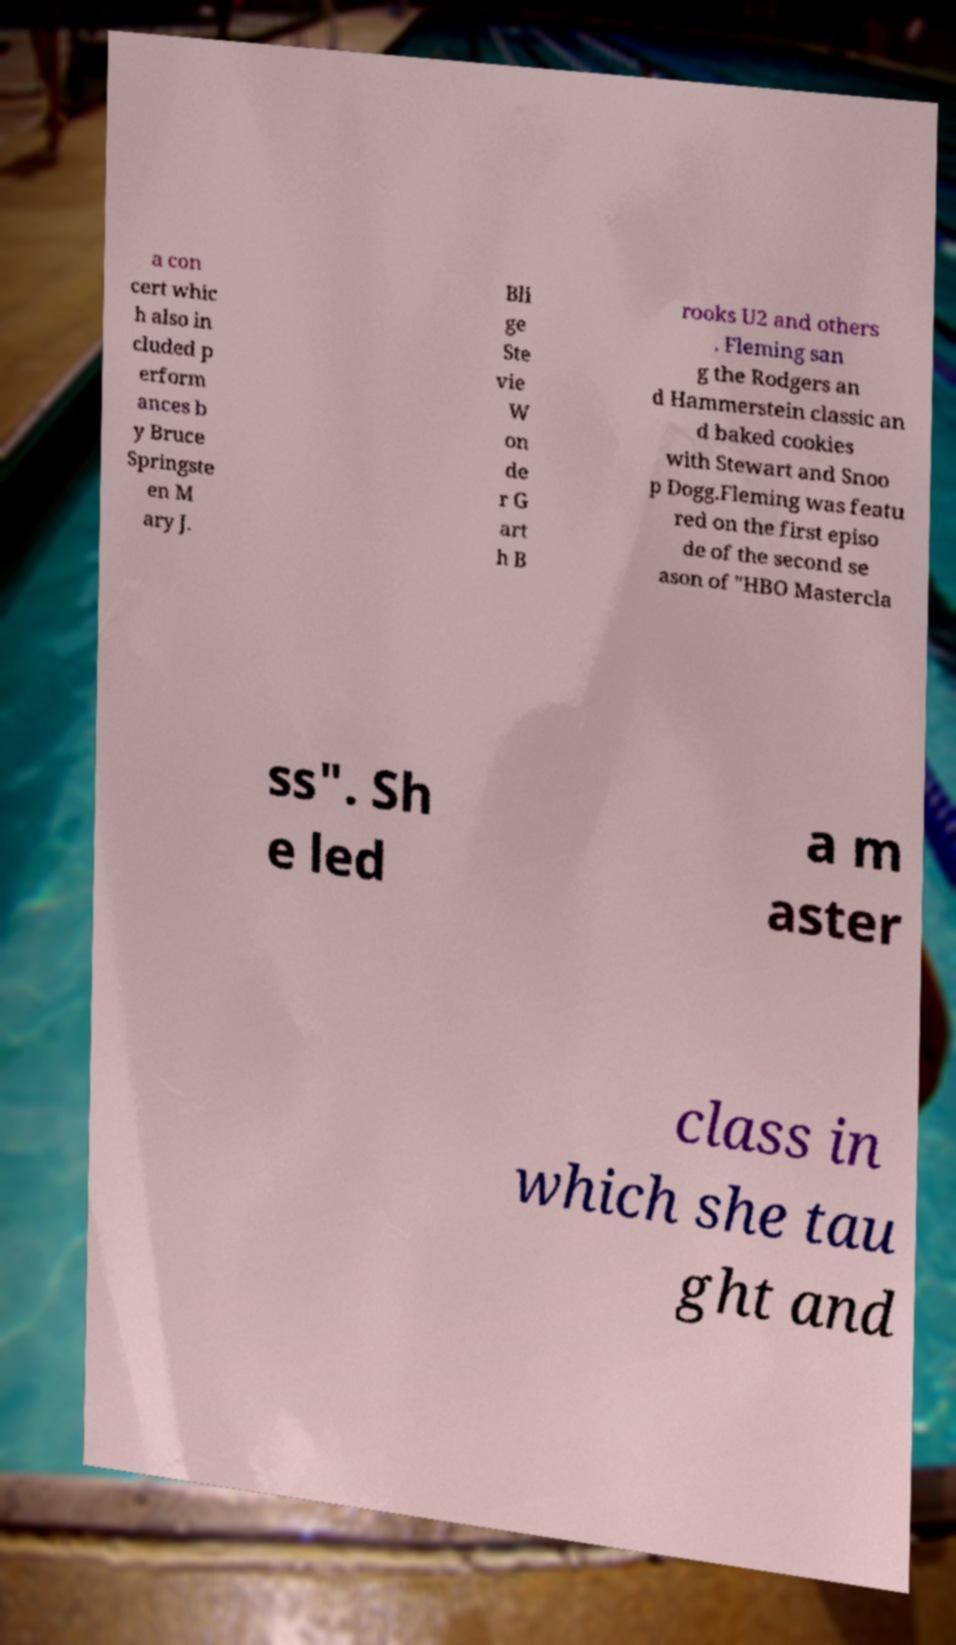Can you read and provide the text displayed in the image?This photo seems to have some interesting text. Can you extract and type it out for me? a con cert whic h also in cluded p erform ances b y Bruce Springste en M ary J. Bli ge Ste vie W on de r G art h B rooks U2 and others . Fleming san g the Rodgers an d Hammerstein classic an d baked cookies with Stewart and Snoo p Dogg.Fleming was featu red on the first episo de of the second se ason of "HBO Mastercla ss". Sh e led a m aster class in which she tau ght and 